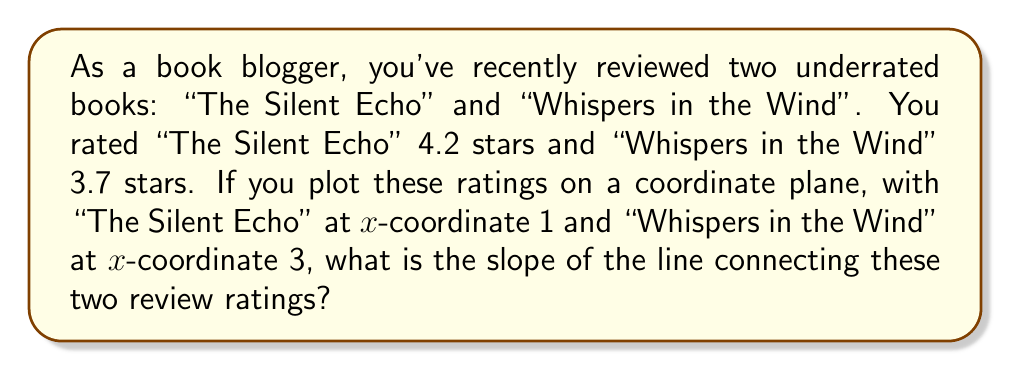Show me your answer to this math problem. To calculate the slope of the line connecting two points, we use the slope formula:

$$ m = \frac{y_2 - y_1}{x_2 - x_1} $$

Where $(x_1, y_1)$ is the first point and $(x_2, y_2)$ is the second point.

In this case:
- Point 1 (The Silent Echo): $(1, 4.2)$
- Point 2 (Whispers in the Wind): $(3, 3.7)$

Let's plug these values into the formula:

$$ m = \frac{3.7 - 4.2}{3 - 1} $$

Simplifying:

$$ m = \frac{-0.5}{2} $$

$$ m = -0.25 $$

Therefore, the slope of the line connecting these two review ratings is -0.25.
Answer: $-0.25$ 